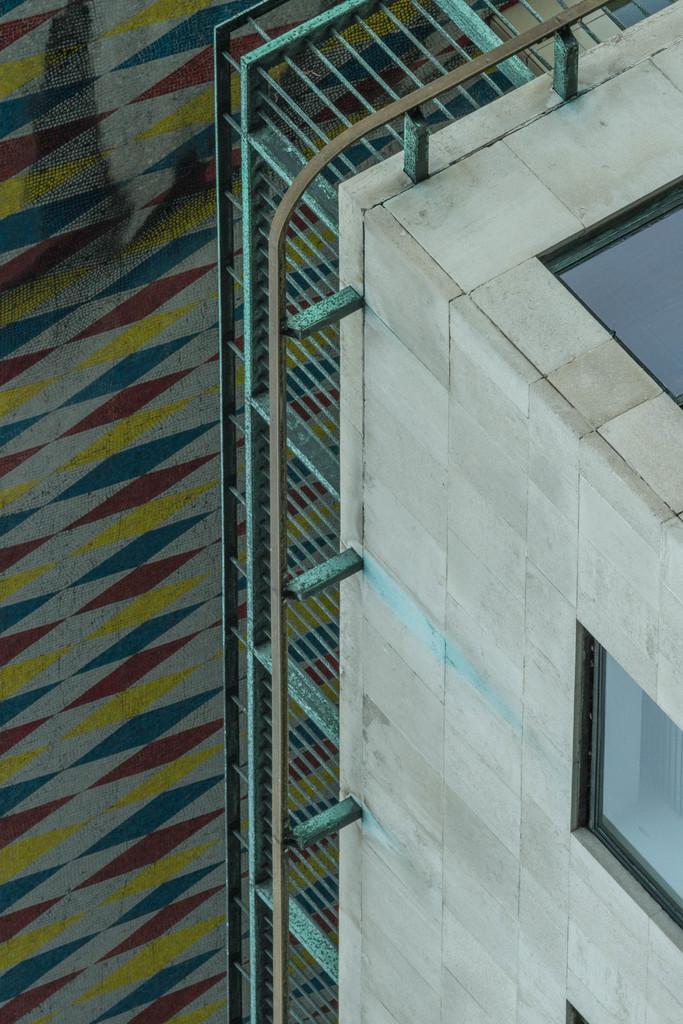Can you describe this image briefly? In this image I can see the building with windows and there is a railing to the building. To the left I can see the surface which is in yellow, red and blue color. 